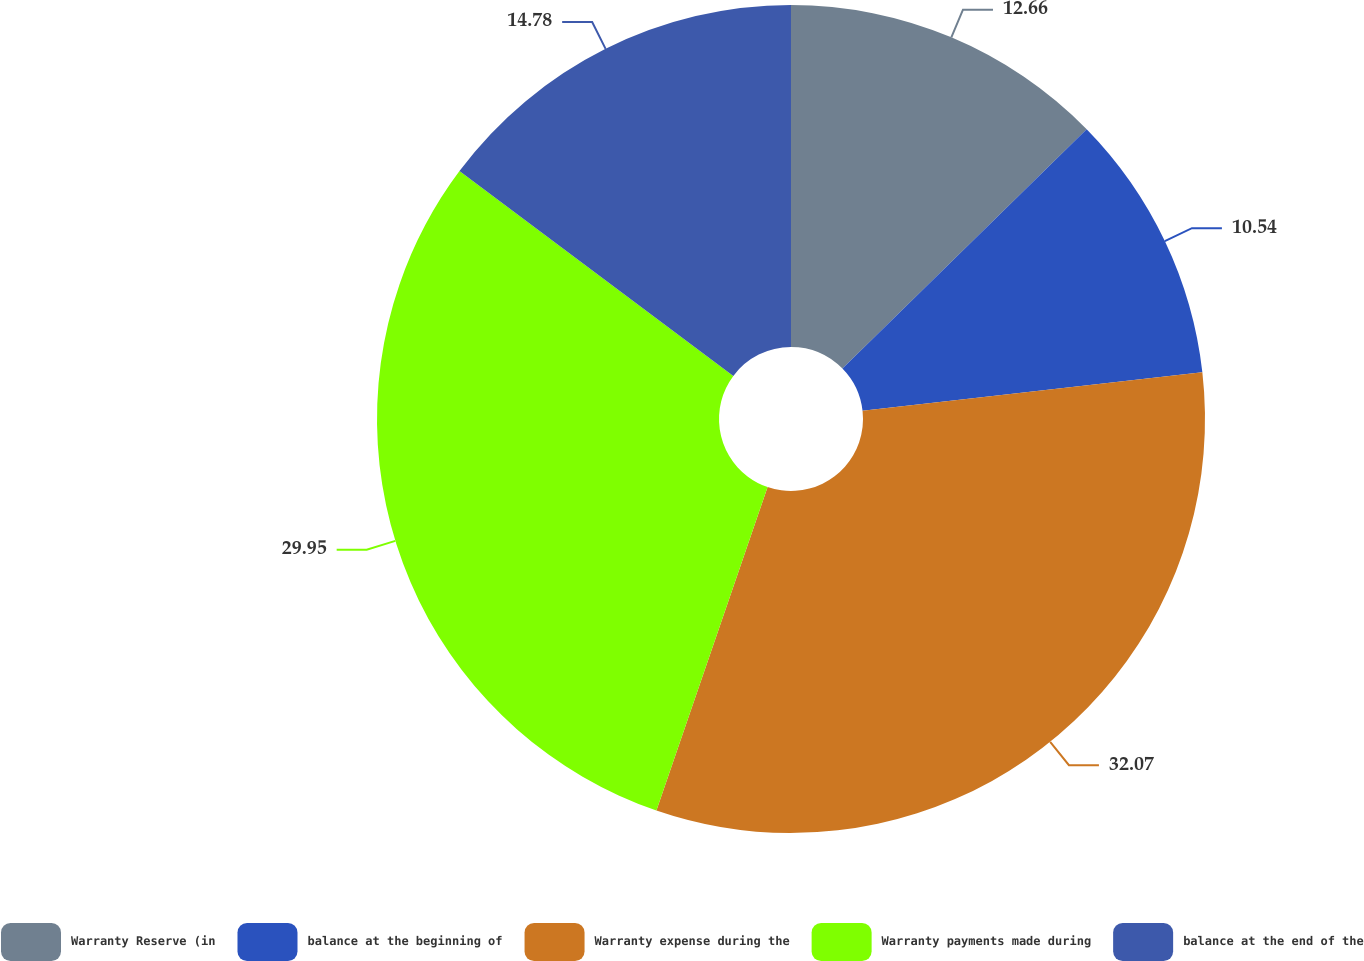Convert chart. <chart><loc_0><loc_0><loc_500><loc_500><pie_chart><fcel>Warranty Reserve (in<fcel>balance at the beginning of<fcel>Warranty expense during the<fcel>Warranty payments made during<fcel>balance at the end of the<nl><fcel>12.66%<fcel>10.54%<fcel>32.07%<fcel>29.95%<fcel>14.78%<nl></chart> 